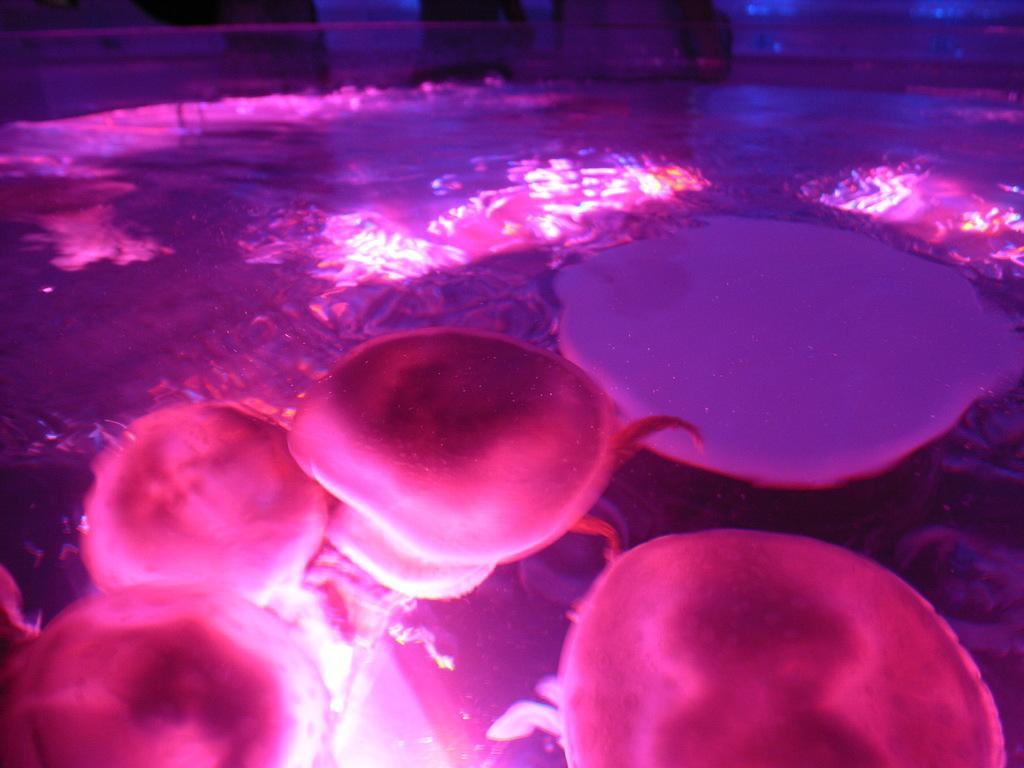What type of animals can be seen in the image? There are water animals in the image. What is the value of the boy walking on the sidewalk in the image? There is no boy walking on the sidewalk in the image, as the only fact provided is about water animals. 